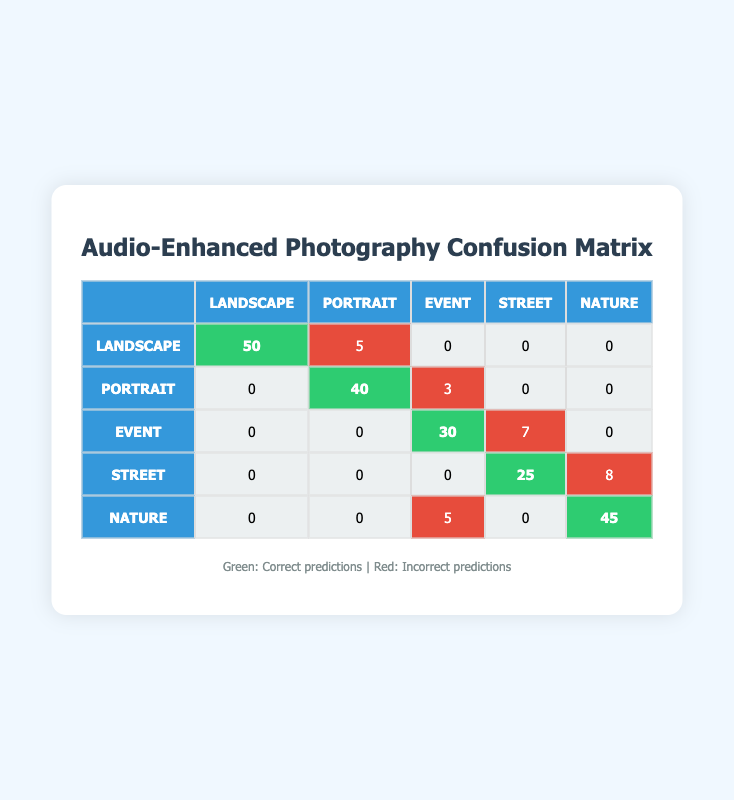What is the count of correctly predicted Landscape images? The count of correctly predicted Landscape images is found on the diagonal of the table where the true label and predicted label match. In the row for Landscape, the count is 50.
Answer: 50 What is the count of incorrectly predicted Portrait images as Event? The table shows that there are 3 Portrait images that were incorrectly predicted as Event. This information is found in the corresponding row for Portrait and column for Event.
Answer: 3 How many Nature images were correctly classified? The correctly classified Nature images can be found on the diagonal of the table under the Nature row where it says 45.
Answer: 45 What is the total number of predictions made for Street images? To find the total predictions for Street, sum the counts of all predictions in the row for Street: 25 (correct) + 8 (incorrectly predicted as Nature) = 33.
Answer: 33 Is the count of incorrectly predicted Landscape images greater than that of incorrectly predicted Nature images? The incorrect Landscape predictions are 5 (predicted as Portrait), and the incorrect Nature predictions are 5 as well (predicted as Event). Since 5 is not greater than 5, the answer is false.
Answer: No What is the average count of correctly classified images for all styles? The total count of correctly classified images is: 50 (Landscape) + 40 (Portrait) + 30 (Event) + 25 (Street) + 45 (Nature) = 190. There are 5 styles, so the average is 190/5 = 38.
Answer: 38 Which style has the highest incorrect prediction count? To find the style with the highest incorrect predictions, look at the rows and sum the counts of mistakes. Landscape has 5, Portrait has 3, Event has 7, Street has 8, and Nature has 5. The highest is 8 for Street.
Answer: Street What is the total number of Event predictions? The total predictions for Event images can be calculated by summing all counts in the Event row: 0 (Landscape) + 0 (Portrait) + 30 (Event) + 7 (predicted as Street) + 5 (predicted as Nature) = 42.
Answer: 42 How many images were correctly predicted across all styles? Add the counts on the diagonal in the confusion matrix: 50 (Landscape) + 40 (Portrait) + 30 (Event) + 25 (Street) + 45 (Nature) = 190.
Answer: 190 